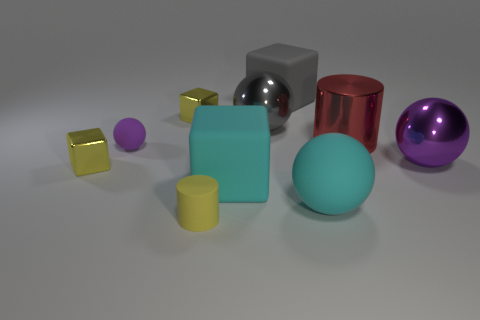Is there a red block of the same size as the gray ball?
Provide a short and direct response. No. Are there more tiny matte objects that are in front of the large gray rubber thing than big red metal objects left of the large red metal cylinder?
Give a very brief answer. Yes. Does the sphere that is left of the small yellow rubber thing have the same material as the yellow cube in front of the gray ball?
Provide a short and direct response. No. There is a yellow rubber thing that is the same size as the purple rubber object; what is its shape?
Provide a short and direct response. Cylinder. Are there any tiny yellow rubber things of the same shape as the purple metallic object?
Your answer should be very brief. No. There is a metal thing that is right of the red thing; is it the same color as the matte sphere that is behind the big purple metallic ball?
Provide a short and direct response. Yes. There is a gray block; are there any matte cubes on the left side of it?
Provide a succinct answer. Yes. There is a cube that is both to the left of the small yellow matte thing and in front of the tiny ball; what is it made of?
Offer a very short reply. Metal. Are the tiny yellow thing behind the large red cylinder and the red thing made of the same material?
Provide a short and direct response. Yes. What material is the red cylinder?
Make the answer very short. Metal. 